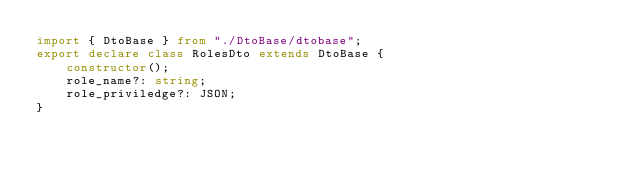Convert code to text. <code><loc_0><loc_0><loc_500><loc_500><_TypeScript_>import { DtoBase } from "./DtoBase/dtobase";
export declare class RolesDto extends DtoBase {
    constructor();
    role_name?: string;
    role_priviledge?: JSON;
}
</code> 